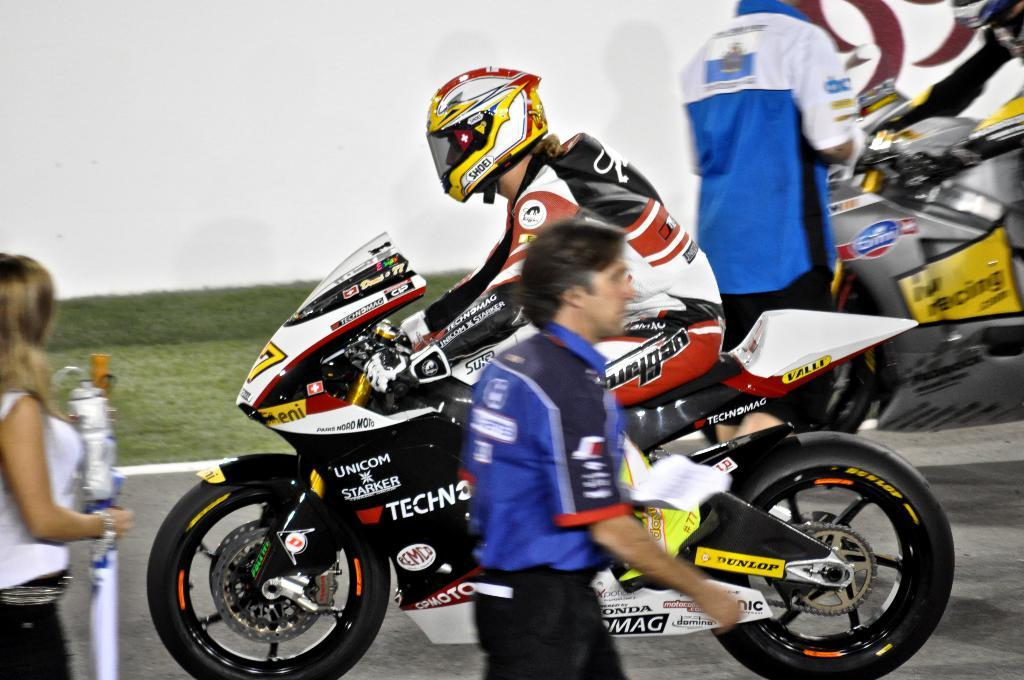How many people are in the image? There is a group of people in the image. What is the position of the people in the image? The people are standing on the ground. What type of clothing are two of the persons wearing? Two persons are wearing jackets. What type of protective gear are two of the persons wearing? Two persons are wearing helmets. What are the two persons with helmets doing in the image? The two persons are riding motorcycles. What can be seen in the background of the image? There is a wall in the background of the image. What type of milk is being poured into the mist in the image? There is no milk or mist present in the image. 